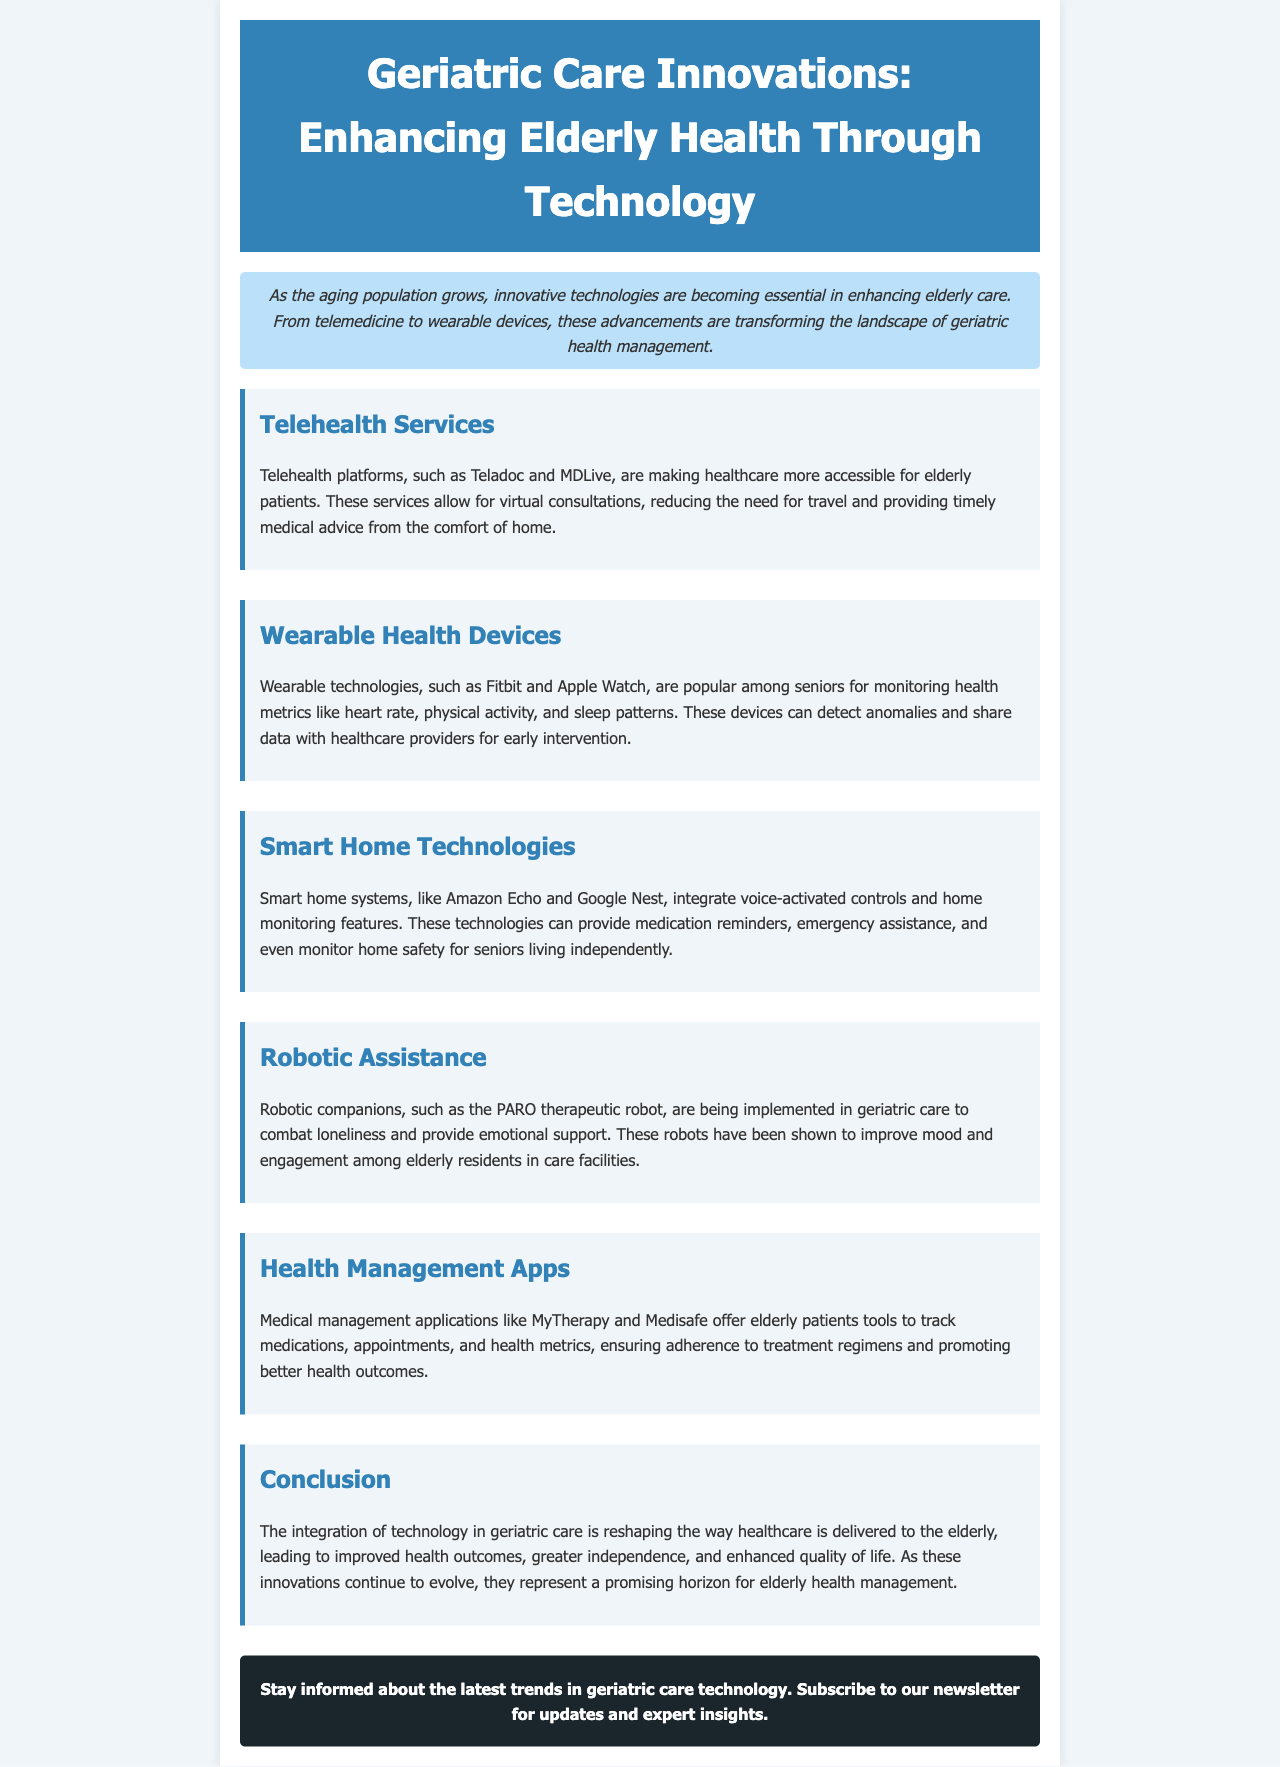What are some telehealth platforms mentioned in the document? The document lists Teladoc and MDLive as examples of telehealth platforms.
Answer: Teladoc, MDLive What do wearable health devices monitor? According to the document, wearable health devices monitor health metrics like heart rate, physical activity, and sleep patterns.
Answer: Heart rate, physical activity, sleep patterns What is the purpose of smart home technologies for seniors? The document states that smart home technologies provide medication reminders, emergency assistance, and monitor home safety.
Answer: Medication reminders, emergency assistance, monitor home safety What is PARO? The document describes PARO as a therapeutic robot used in geriatric care to combat loneliness and provide emotional support.
Answer: Therapeutic robot How do health management apps benefit elderly patients? The document explains that health management apps help track medications, appointments, and health metrics, ensuring adherence to treatment regimens.
Answer: Ensure adherence to treatment regimens What is the overall conclusion of the newsletter? The conclusion of the newsletter highlights the positive impacts of technology integration in geriatric care.
Answer: Improved health outcomes, greater independence, enhanced quality of life 